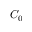<formula> <loc_0><loc_0><loc_500><loc_500>C _ { 0 }</formula> 